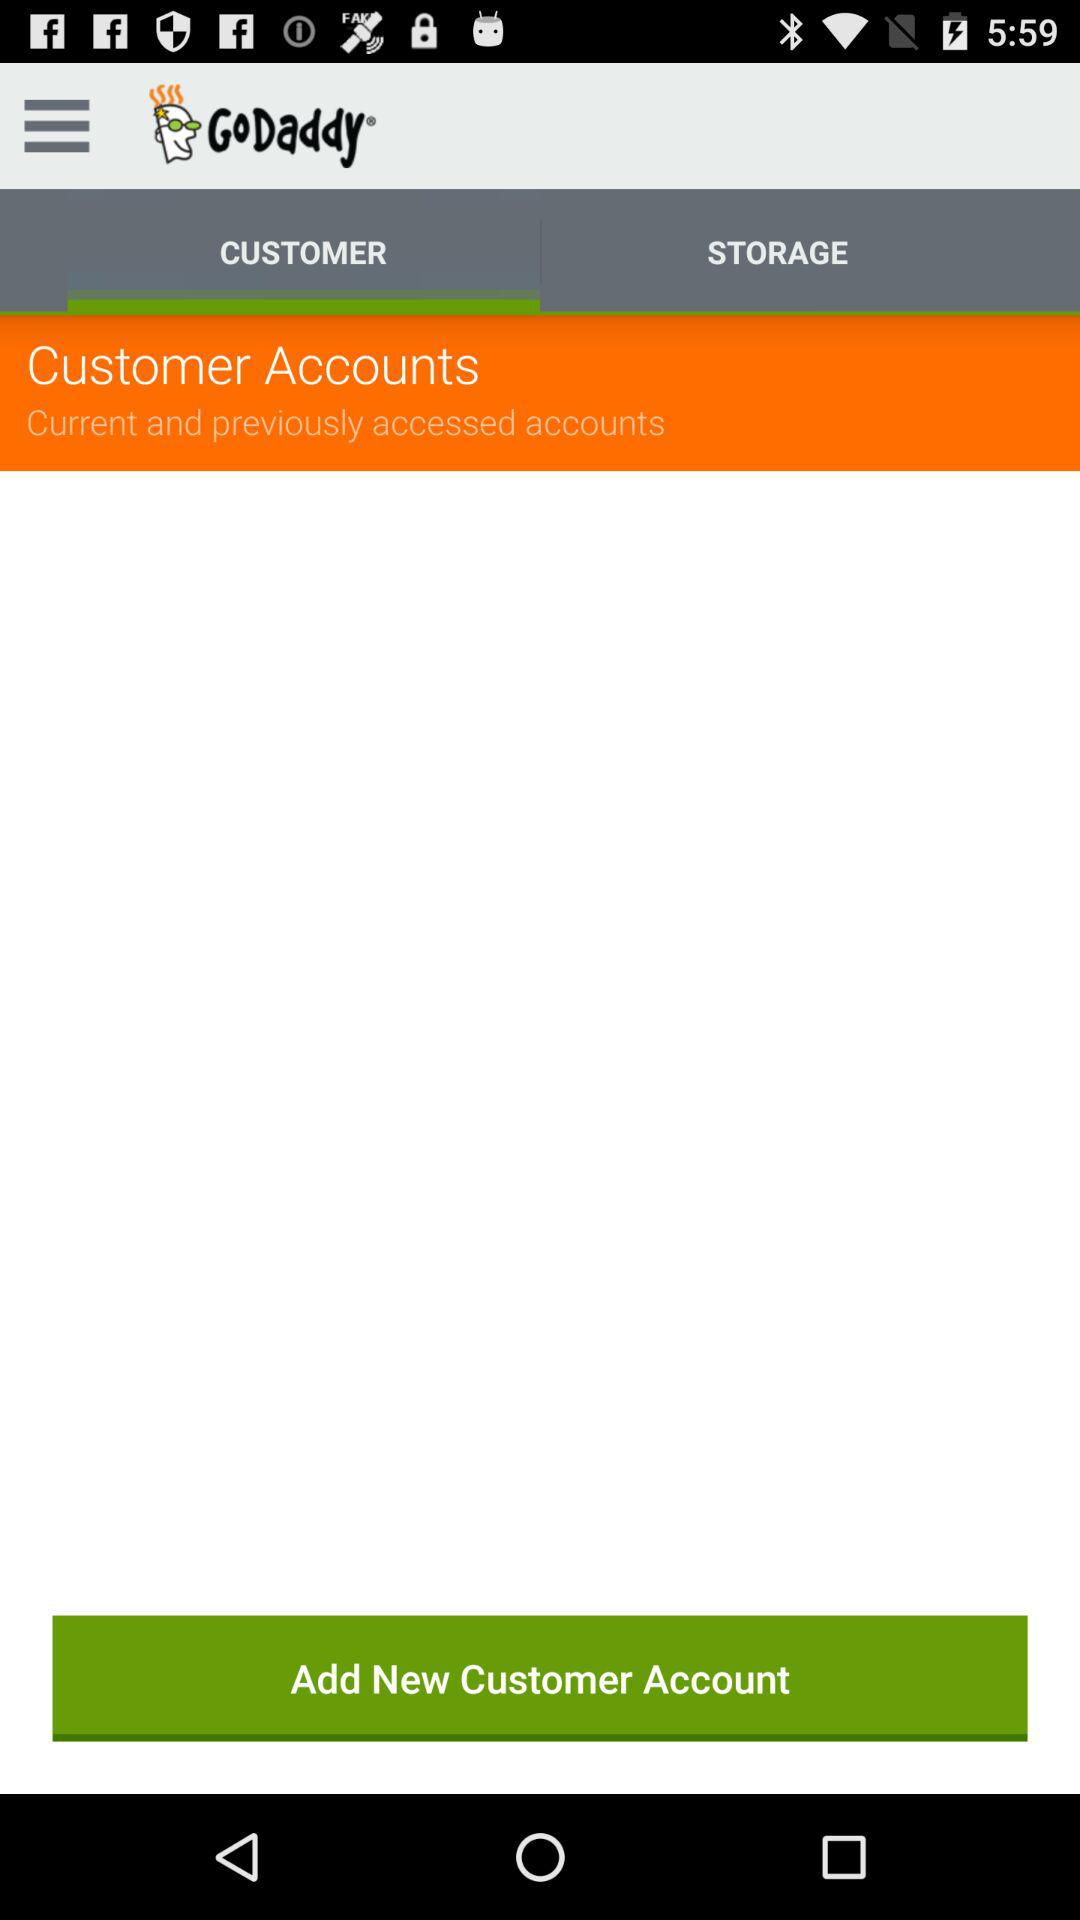What is the application Name? The application name is "GoDaddy". 